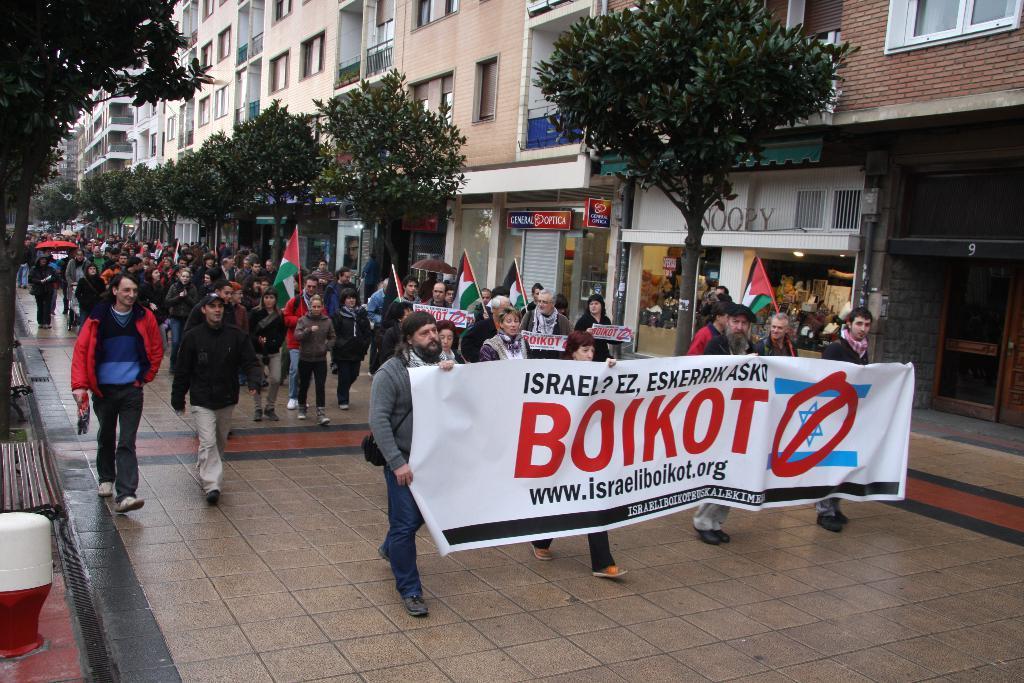Could you give a brief overview of what you see in this image? In this image I can see there are group of persons walking on the road , in the foreground I can see a four persons holding a hoarding board and I can see a text written on that ,at the top I can see buildings and trees. 